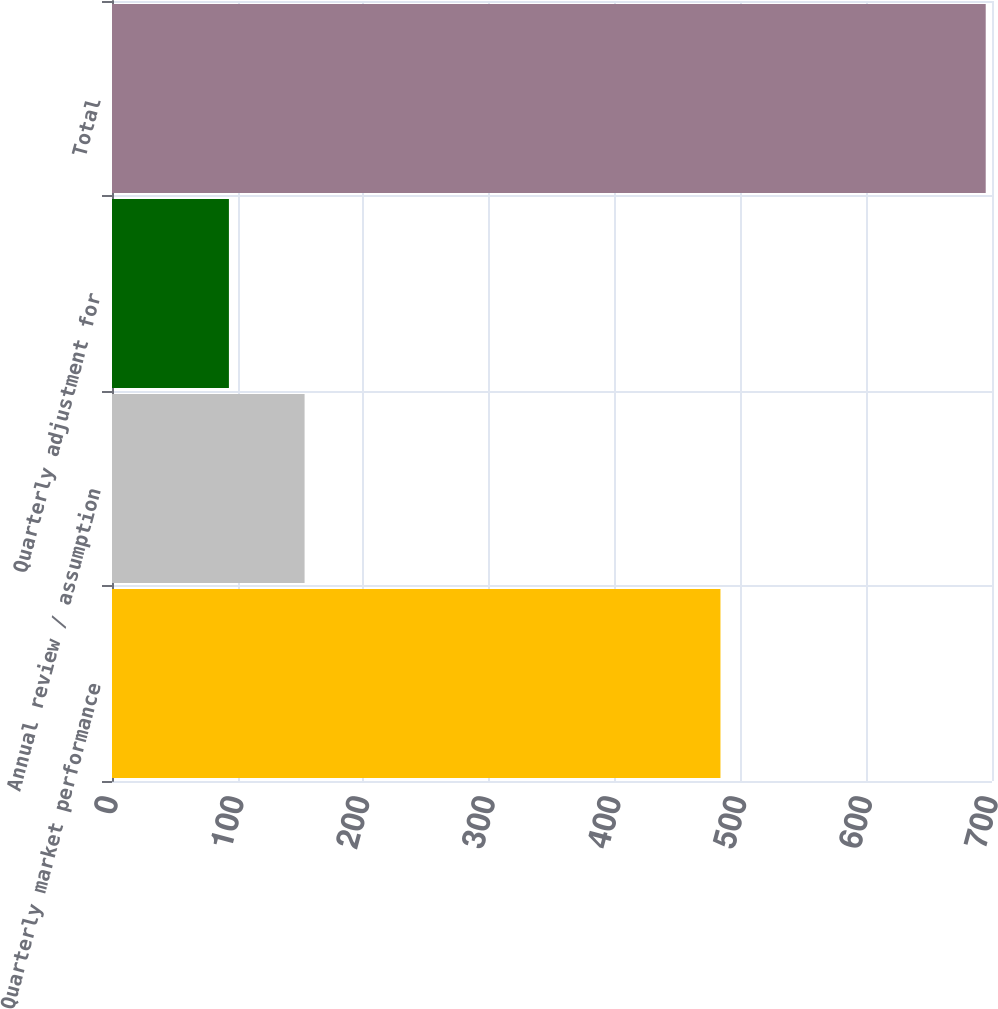Convert chart. <chart><loc_0><loc_0><loc_500><loc_500><bar_chart><fcel>Quarterly market performance<fcel>Annual review / assumption<fcel>Quarterly adjustment for<fcel>Total<nl><fcel>484<fcel>153.2<fcel>93<fcel>695<nl></chart> 